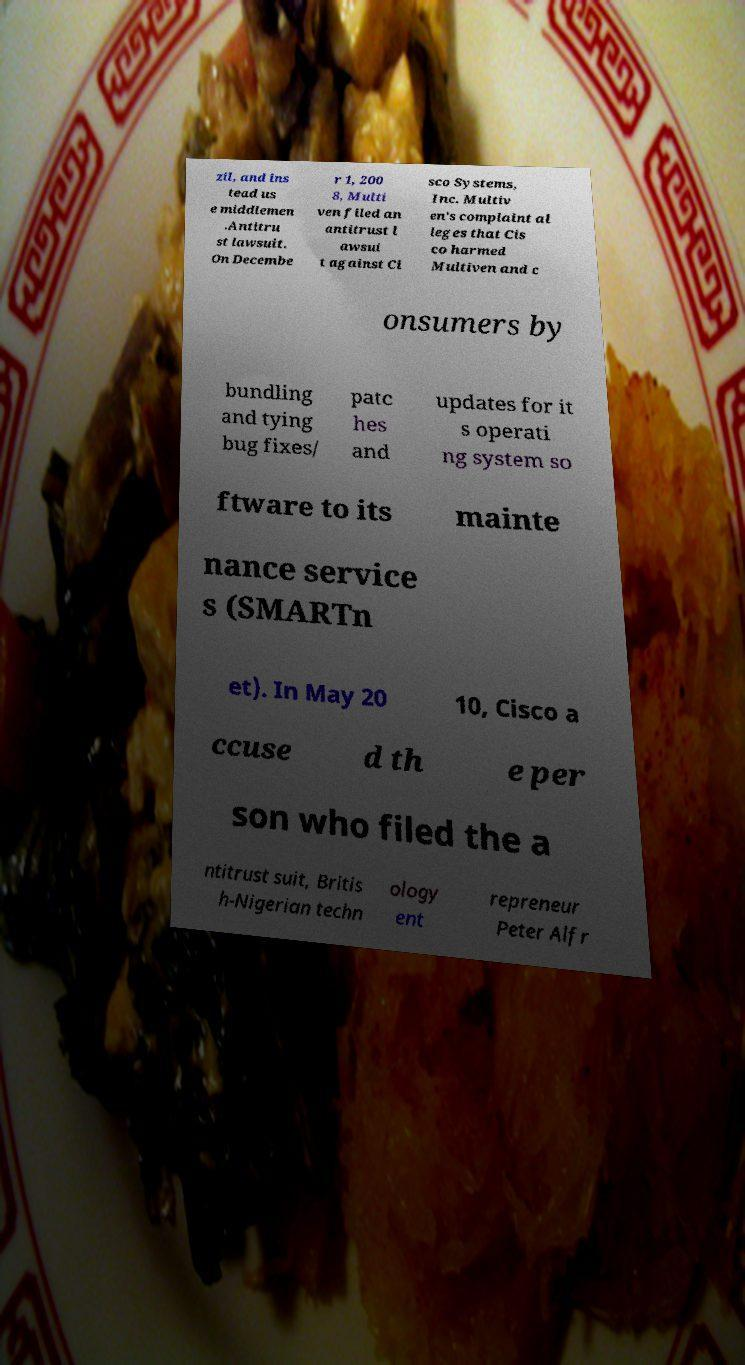For documentation purposes, I need the text within this image transcribed. Could you provide that? zil, and ins tead us e middlemen .Antitru st lawsuit. On Decembe r 1, 200 8, Multi ven filed an antitrust l awsui t against Ci sco Systems, Inc. Multiv en's complaint al leges that Cis co harmed Multiven and c onsumers by bundling and tying bug fixes/ patc hes and updates for it s operati ng system so ftware to its mainte nance service s (SMARTn et). In May 20 10, Cisco a ccuse d th e per son who filed the a ntitrust suit, Britis h-Nigerian techn ology ent repreneur Peter Alfr 